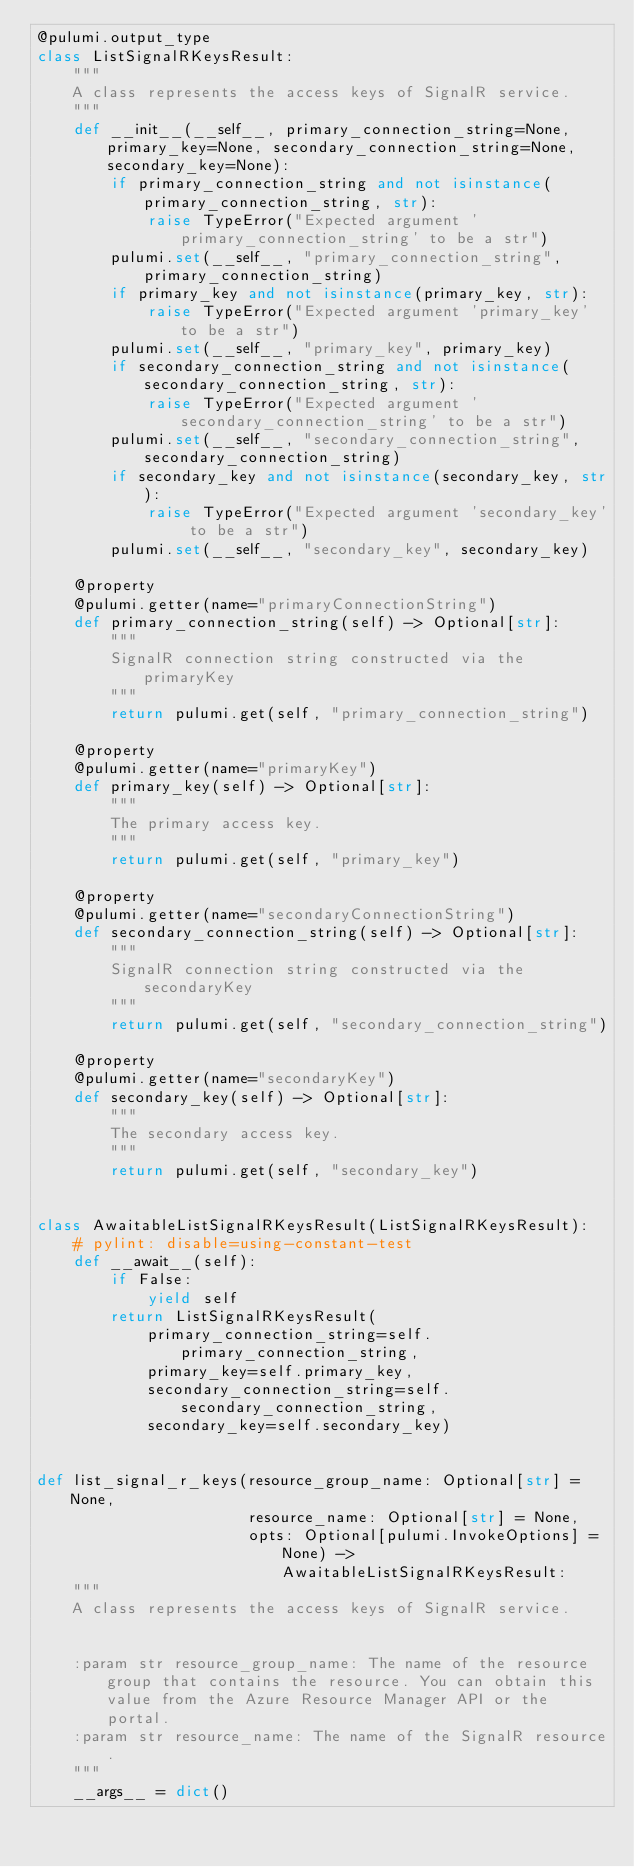<code> <loc_0><loc_0><loc_500><loc_500><_Python_>@pulumi.output_type
class ListSignalRKeysResult:
    """
    A class represents the access keys of SignalR service.
    """
    def __init__(__self__, primary_connection_string=None, primary_key=None, secondary_connection_string=None, secondary_key=None):
        if primary_connection_string and not isinstance(primary_connection_string, str):
            raise TypeError("Expected argument 'primary_connection_string' to be a str")
        pulumi.set(__self__, "primary_connection_string", primary_connection_string)
        if primary_key and not isinstance(primary_key, str):
            raise TypeError("Expected argument 'primary_key' to be a str")
        pulumi.set(__self__, "primary_key", primary_key)
        if secondary_connection_string and not isinstance(secondary_connection_string, str):
            raise TypeError("Expected argument 'secondary_connection_string' to be a str")
        pulumi.set(__self__, "secondary_connection_string", secondary_connection_string)
        if secondary_key and not isinstance(secondary_key, str):
            raise TypeError("Expected argument 'secondary_key' to be a str")
        pulumi.set(__self__, "secondary_key", secondary_key)

    @property
    @pulumi.getter(name="primaryConnectionString")
    def primary_connection_string(self) -> Optional[str]:
        """
        SignalR connection string constructed via the primaryKey
        """
        return pulumi.get(self, "primary_connection_string")

    @property
    @pulumi.getter(name="primaryKey")
    def primary_key(self) -> Optional[str]:
        """
        The primary access key.
        """
        return pulumi.get(self, "primary_key")

    @property
    @pulumi.getter(name="secondaryConnectionString")
    def secondary_connection_string(self) -> Optional[str]:
        """
        SignalR connection string constructed via the secondaryKey
        """
        return pulumi.get(self, "secondary_connection_string")

    @property
    @pulumi.getter(name="secondaryKey")
    def secondary_key(self) -> Optional[str]:
        """
        The secondary access key.
        """
        return pulumi.get(self, "secondary_key")


class AwaitableListSignalRKeysResult(ListSignalRKeysResult):
    # pylint: disable=using-constant-test
    def __await__(self):
        if False:
            yield self
        return ListSignalRKeysResult(
            primary_connection_string=self.primary_connection_string,
            primary_key=self.primary_key,
            secondary_connection_string=self.secondary_connection_string,
            secondary_key=self.secondary_key)


def list_signal_r_keys(resource_group_name: Optional[str] = None,
                       resource_name: Optional[str] = None,
                       opts: Optional[pulumi.InvokeOptions] = None) -> AwaitableListSignalRKeysResult:
    """
    A class represents the access keys of SignalR service.


    :param str resource_group_name: The name of the resource group that contains the resource. You can obtain this value from the Azure Resource Manager API or the portal.
    :param str resource_name: The name of the SignalR resource.
    """
    __args__ = dict()</code> 